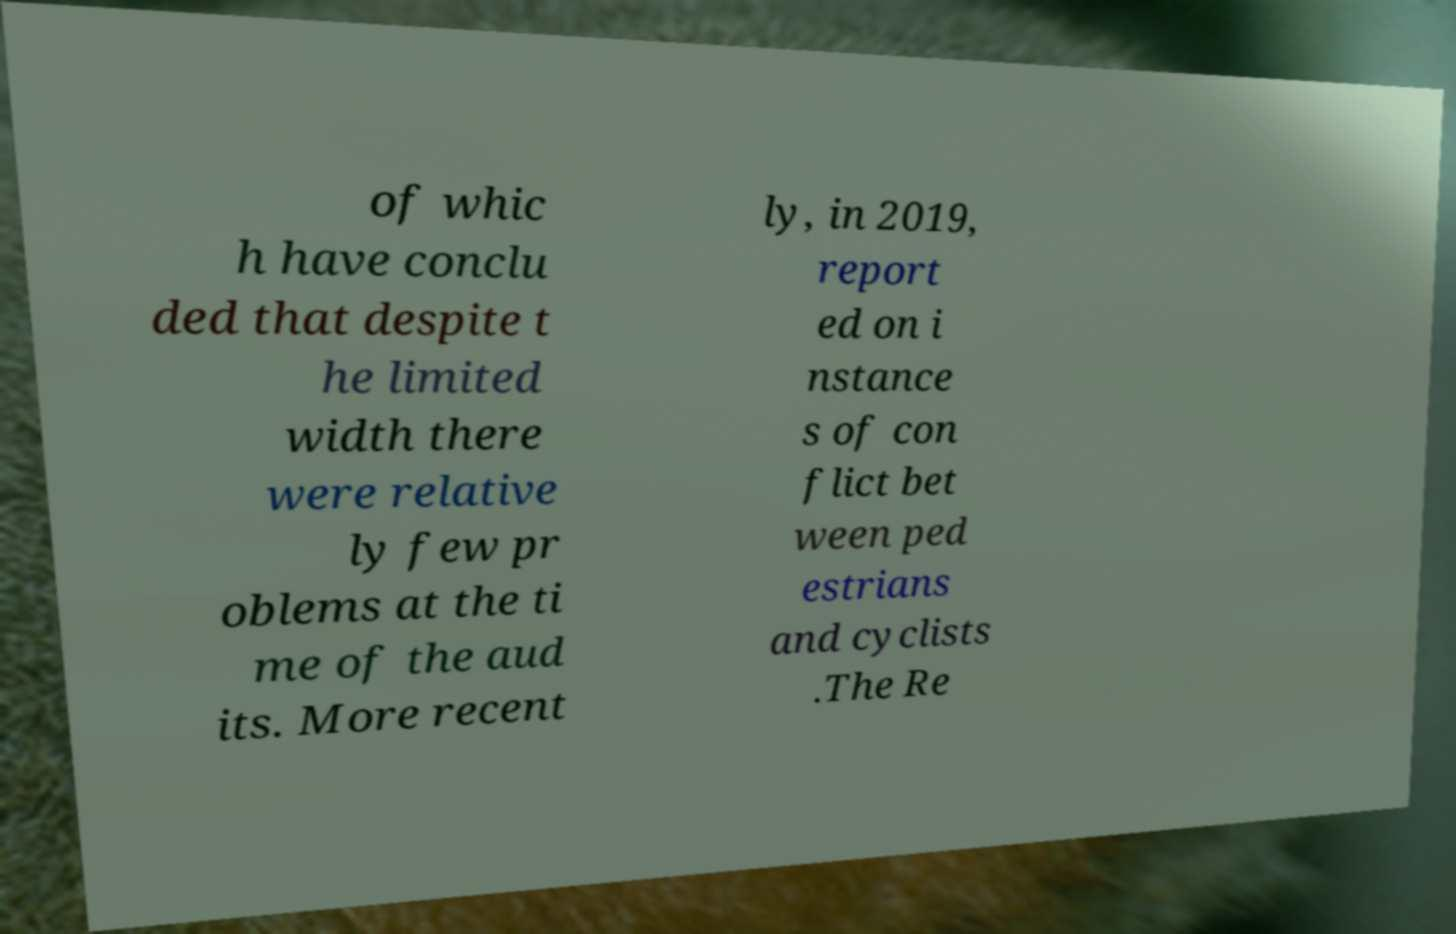I need the written content from this picture converted into text. Can you do that? of whic h have conclu ded that despite t he limited width there were relative ly few pr oblems at the ti me of the aud its. More recent ly, in 2019, report ed on i nstance s of con flict bet ween ped estrians and cyclists .The Re 